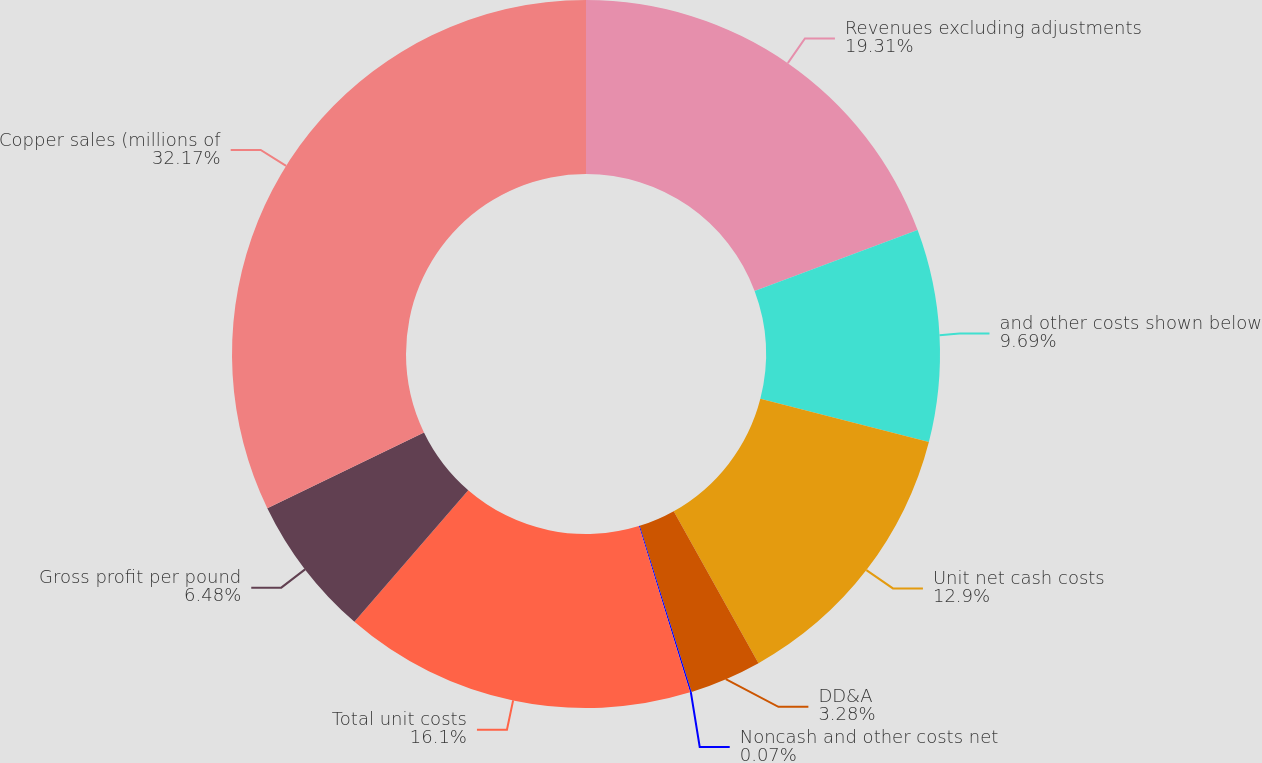Convert chart. <chart><loc_0><loc_0><loc_500><loc_500><pie_chart><fcel>Revenues excluding adjustments<fcel>and other costs shown below<fcel>Unit net cash costs<fcel>DD&A<fcel>Noncash and other costs net<fcel>Total unit costs<fcel>Gross profit per pound<fcel>Copper sales (millions of<nl><fcel>19.31%<fcel>9.69%<fcel>12.9%<fcel>3.28%<fcel>0.07%<fcel>16.1%<fcel>6.48%<fcel>32.17%<nl></chart> 